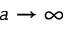Convert formula to latex. <formula><loc_0><loc_0><loc_500><loc_500>a \to \infty</formula> 